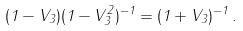Convert formula to latex. <formula><loc_0><loc_0><loc_500><loc_500>( 1 - V _ { 3 } ) ( 1 - V _ { 3 } ^ { 2 } ) ^ { - 1 } = ( 1 + V _ { 3 } ) ^ { - 1 } \, .</formula> 